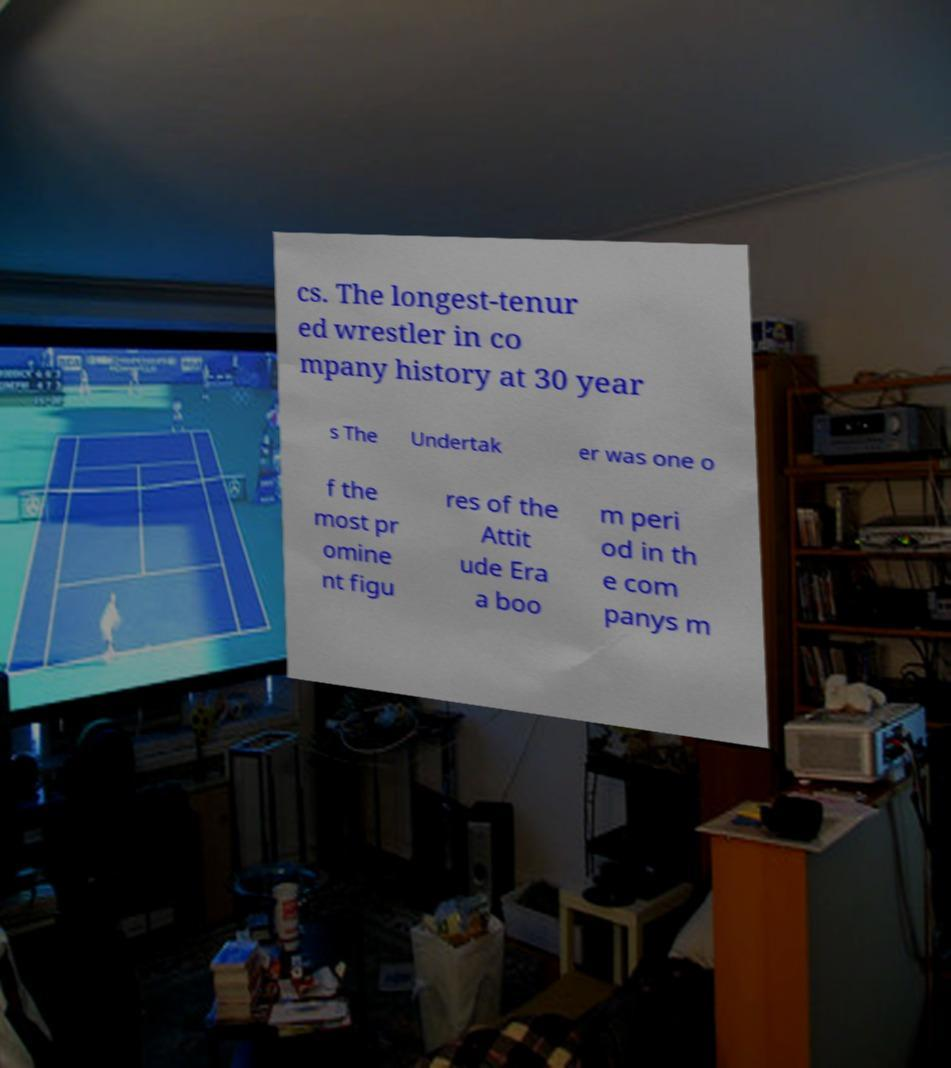Could you extract and type out the text from this image? cs. The longest-tenur ed wrestler in co mpany history at 30 year s The Undertak er was one o f the most pr omine nt figu res of the Attit ude Era a boo m peri od in th e com panys m 